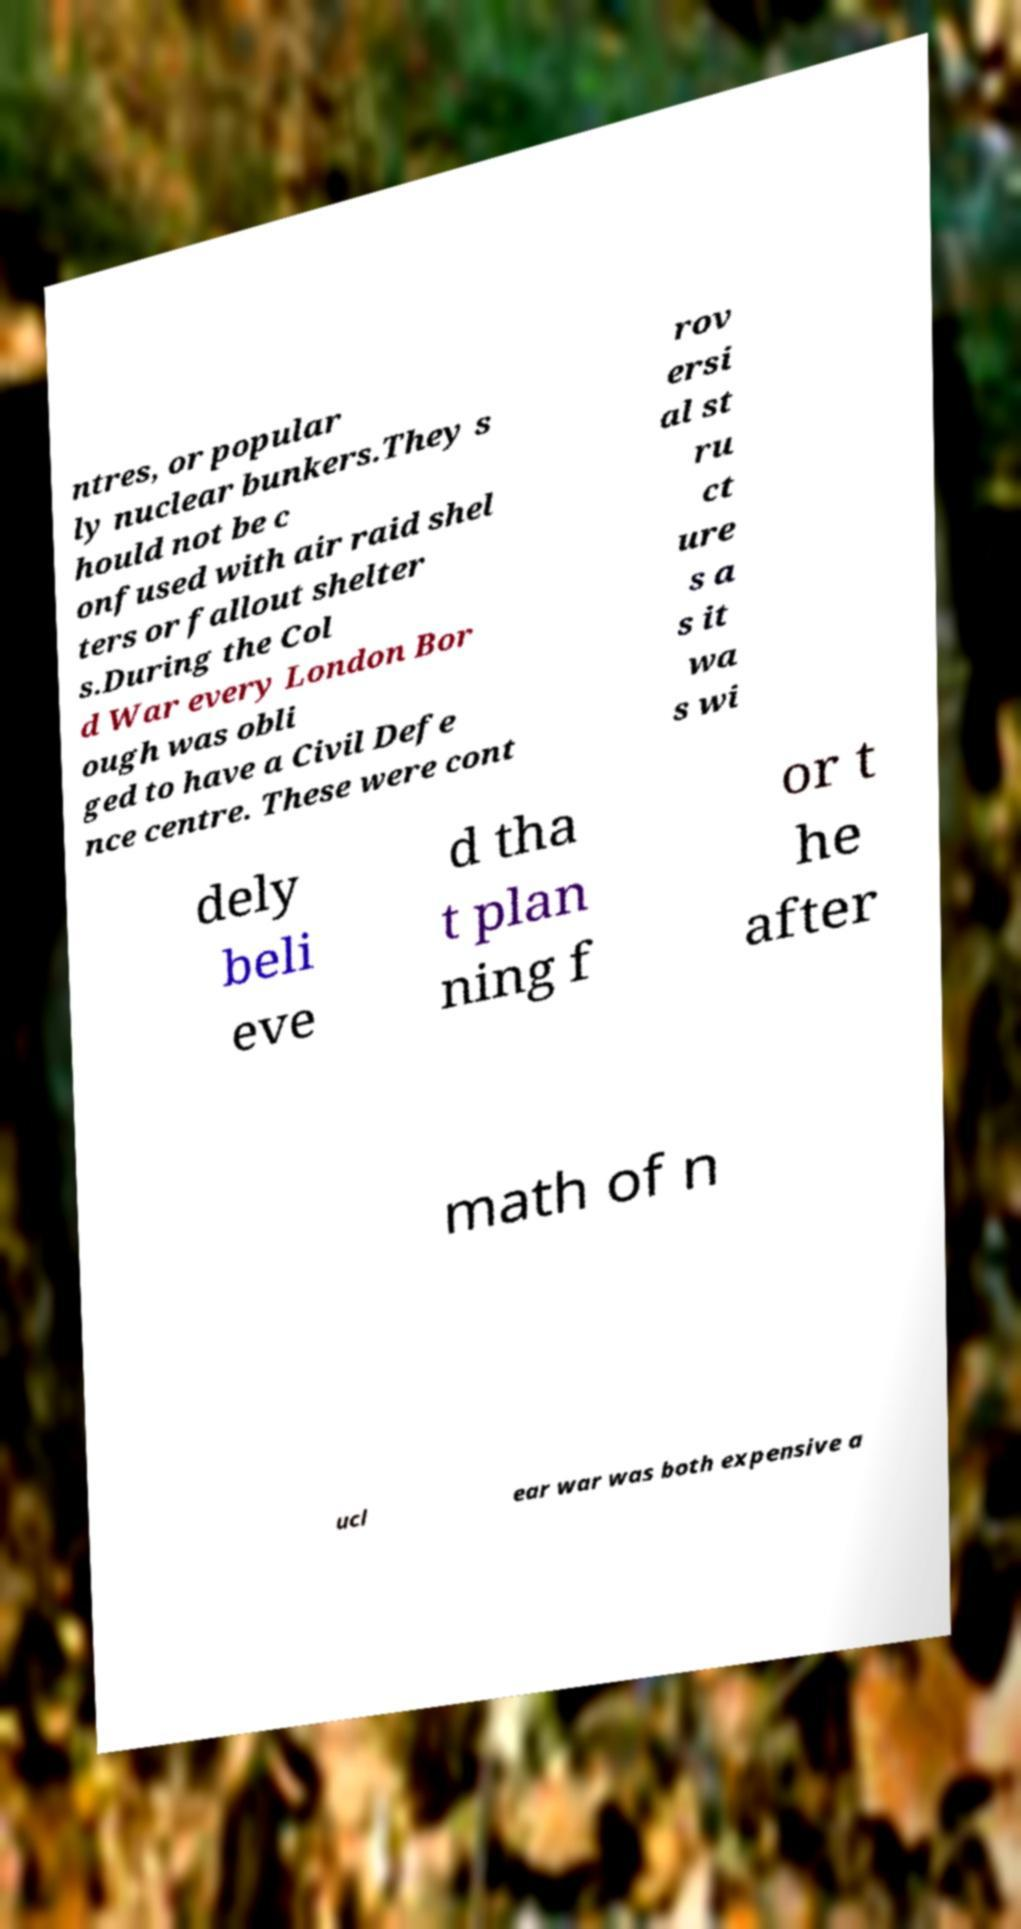There's text embedded in this image that I need extracted. Can you transcribe it verbatim? ntres, or popular ly nuclear bunkers.They s hould not be c onfused with air raid shel ters or fallout shelter s.During the Col d War every London Bor ough was obli ged to have a Civil Defe nce centre. These were cont rov ersi al st ru ct ure s a s it wa s wi dely beli eve d tha t plan ning f or t he after math of n ucl ear war was both expensive a 